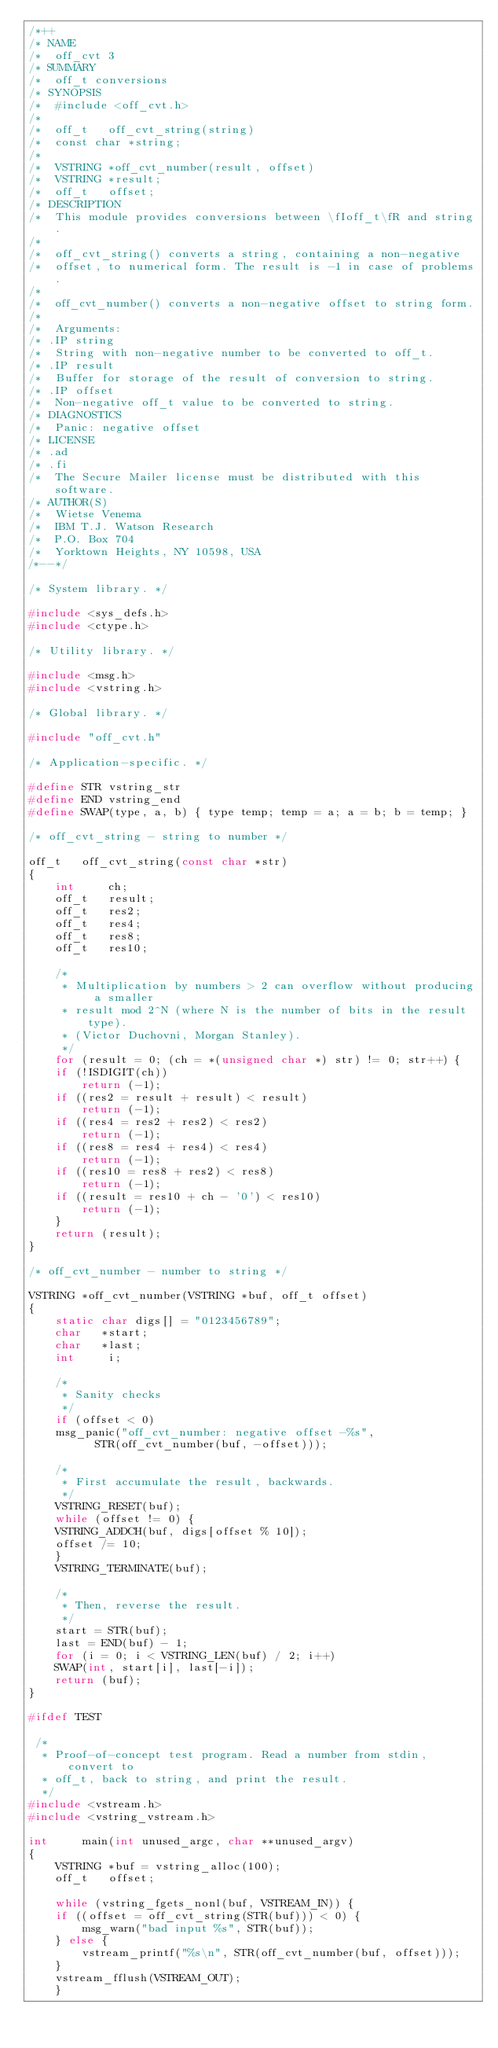<code> <loc_0><loc_0><loc_500><loc_500><_C_>/*++
/* NAME
/*	off_cvt 3
/* SUMMARY
/*	off_t conversions
/* SYNOPSIS
/*	#include <off_cvt.h>
/*
/*	off_t	off_cvt_string(string)
/*	const char *string;
/*
/*	VSTRING	*off_cvt_number(result, offset)
/*	VSTRING	*result;
/*	off_t	offset;
/* DESCRIPTION
/*	This module provides conversions between \fIoff_t\fR and string.
/*
/*	off_cvt_string() converts a string, containing a non-negative
/*	offset, to numerical form. The result is -1 in case of problems.
/*
/*	off_cvt_number() converts a non-negative offset to string form.
/*
/*	Arguments:
/* .IP string
/*	String with non-negative number to be converted to off_t.
/* .IP result
/*	Buffer for storage of the result of conversion to string.
/* .IP offset
/*	Non-negative off_t value to be converted to string.
/* DIAGNOSTICS
/*	Panic: negative offset
/* LICENSE
/* .ad
/* .fi
/*	The Secure Mailer license must be distributed with this software.
/* AUTHOR(S)
/*	Wietse Venema
/*	IBM T.J. Watson Research
/*	P.O. Box 704
/*	Yorktown Heights, NY 10598, USA
/*--*/

/* System library. */

#include <sys_defs.h>
#include <ctype.h>

/* Utility library. */

#include <msg.h>
#include <vstring.h>

/* Global library. */

#include "off_cvt.h"

/* Application-specific. */

#define STR	vstring_str
#define END	vstring_end
#define SWAP(type, a, b) { type temp; temp = a; a = b; b = temp; }

/* off_cvt_string - string to number */

off_t   off_cvt_string(const char *str)
{
    int     ch;
    off_t   result;
    off_t   res2;
    off_t   res4;
    off_t   res8;
    off_t   res10;

    /*
     * Multiplication by numbers > 2 can overflow without producing a smaller
     * result mod 2^N (where N is the number of bits in the result type).
     * (Victor Duchovni, Morgan Stanley).
     */
    for (result = 0; (ch = *(unsigned char *) str) != 0; str++) {
	if (!ISDIGIT(ch))
	    return (-1);
	if ((res2 = result + result) < result)
	    return (-1);
	if ((res4 = res2 + res2) < res2)
	    return (-1);
	if ((res8 = res4 + res4) < res4)
	    return (-1);
	if ((res10 = res8 + res2) < res8)
	    return (-1);
	if ((result = res10 + ch - '0') < res10)
	    return (-1);
    }
    return (result);
}

/* off_cvt_number - number to string */

VSTRING *off_cvt_number(VSTRING *buf, off_t offset)
{
    static char digs[] = "0123456789";
    char   *start;
    char   *last;
    int     i;

    /*
     * Sanity checks
     */
    if (offset < 0)
	msg_panic("off_cvt_number: negative offset -%s",
		  STR(off_cvt_number(buf, -offset)));

    /*
     * First accumulate the result, backwards.
     */
    VSTRING_RESET(buf);
    while (offset != 0) {
	VSTRING_ADDCH(buf, digs[offset % 10]);
	offset /= 10;
    }
    VSTRING_TERMINATE(buf);

    /*
     * Then, reverse the result.
     */
    start = STR(buf);
    last = END(buf) - 1;
    for (i = 0; i < VSTRING_LEN(buf) / 2; i++)
	SWAP(int, start[i], last[-i]);
    return (buf);
}

#ifdef TEST

 /*
  * Proof-of-concept test program. Read a number from stdin, convert to
  * off_t, back to string, and print the result.
  */
#include <vstream.h>
#include <vstring_vstream.h>

int     main(int unused_argc, char **unused_argv)
{
    VSTRING *buf = vstring_alloc(100);
    off_t   offset;

    while (vstring_fgets_nonl(buf, VSTREAM_IN)) {
	if ((offset = off_cvt_string(STR(buf))) < 0) {
	    msg_warn("bad input %s", STR(buf));
	} else {
	    vstream_printf("%s\n", STR(off_cvt_number(buf, offset)));
	}
	vstream_fflush(VSTREAM_OUT);
    }</code> 